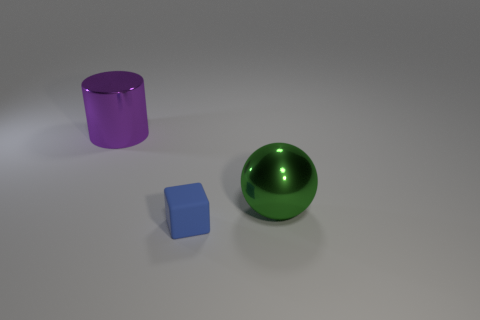Are there any other things that are the same size as the matte cube?
Your answer should be compact. No. Are there any other matte objects of the same shape as the small object?
Provide a short and direct response. No. Are there any rubber blocks that have the same size as the metal ball?
Offer a very short reply. No. Is the small cube made of the same material as the green thing to the right of the blue matte object?
Ensure brevity in your answer.  No. Is the number of tiny matte objects greater than the number of yellow shiny balls?
Your response must be concise. Yes. How many cubes are either blue rubber objects or big purple metallic objects?
Ensure brevity in your answer.  1. What color is the small block?
Your answer should be compact. Blue. Do the metal object to the right of the cylinder and the metal object that is to the left of the cube have the same size?
Your answer should be very brief. Yes. Are there fewer big green balls than small cyan things?
Provide a succinct answer. No. How many blue cubes are to the left of the big purple shiny cylinder?
Your answer should be very brief. 0. 